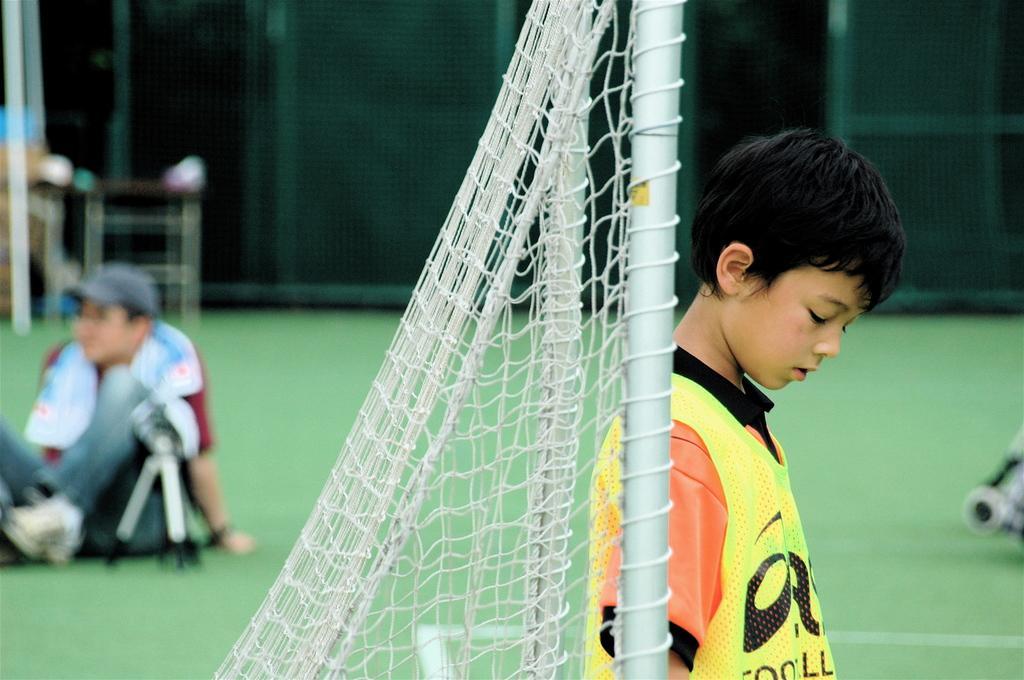Describe this image in one or two sentences. In this image we can see a boy on the right side and behind him there is a net to the poles. In the background the image is blur but we can see a person is sitting on the ground, welded mesh wire and other objects. 